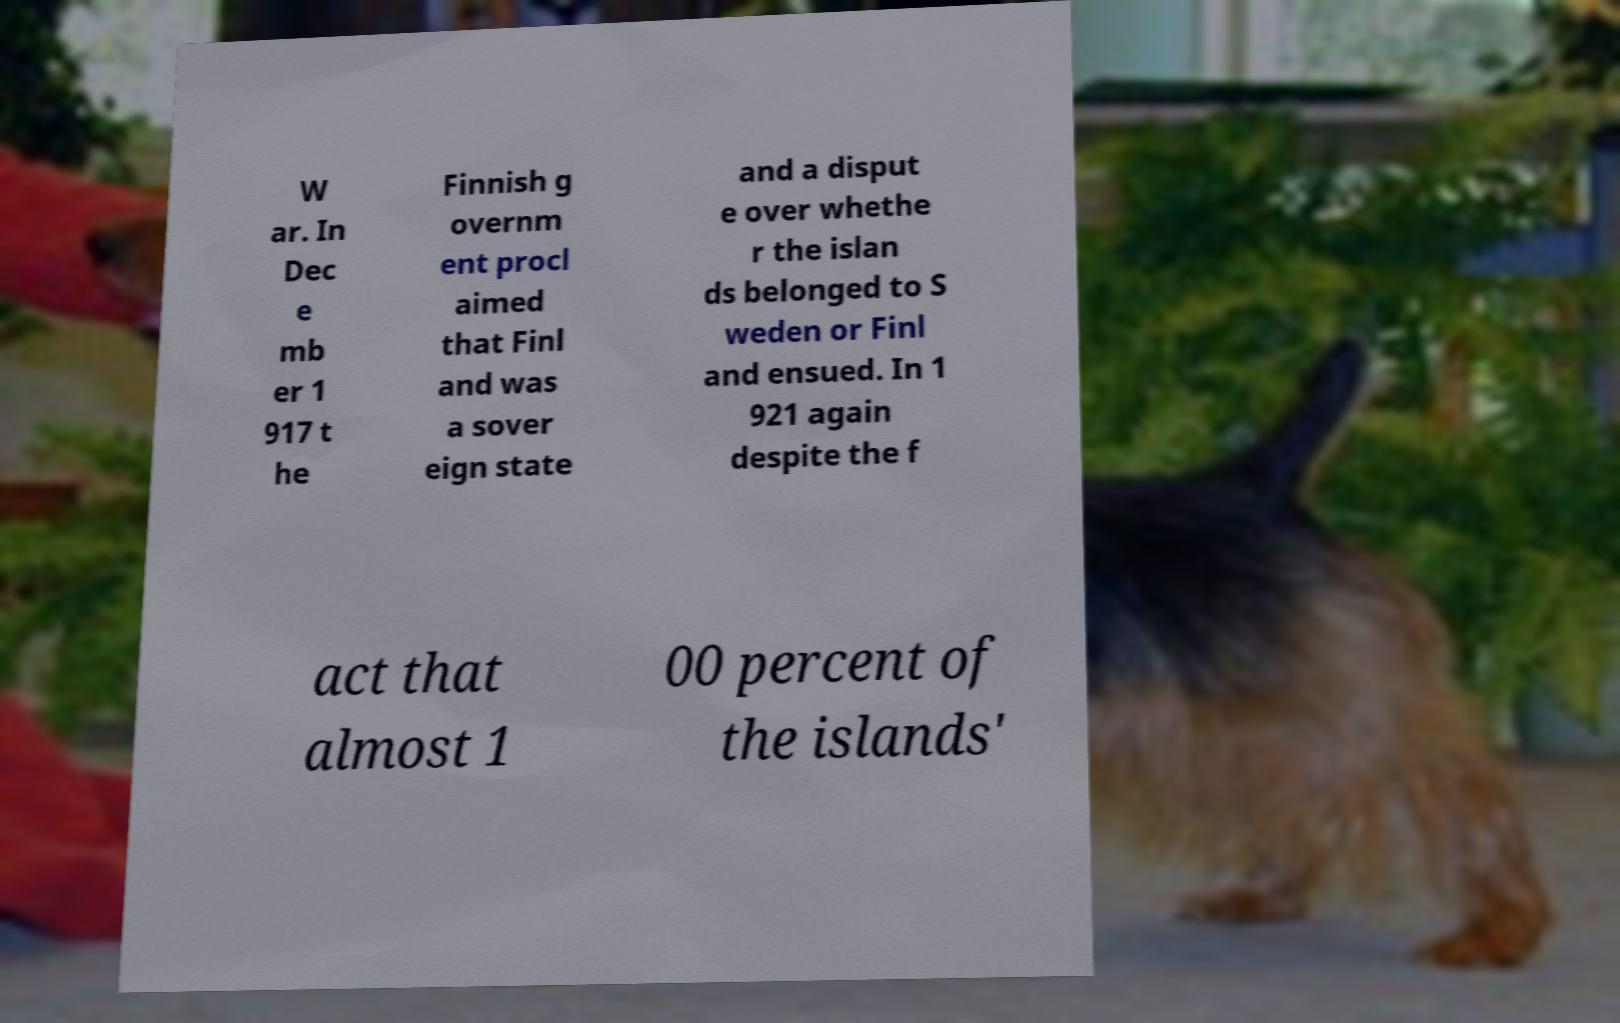For documentation purposes, I need the text within this image transcribed. Could you provide that? W ar. In Dec e mb er 1 917 t he Finnish g overnm ent procl aimed that Finl and was a sover eign state and a disput e over whethe r the islan ds belonged to S weden or Finl and ensued. In 1 921 again despite the f act that almost 1 00 percent of the islands' 